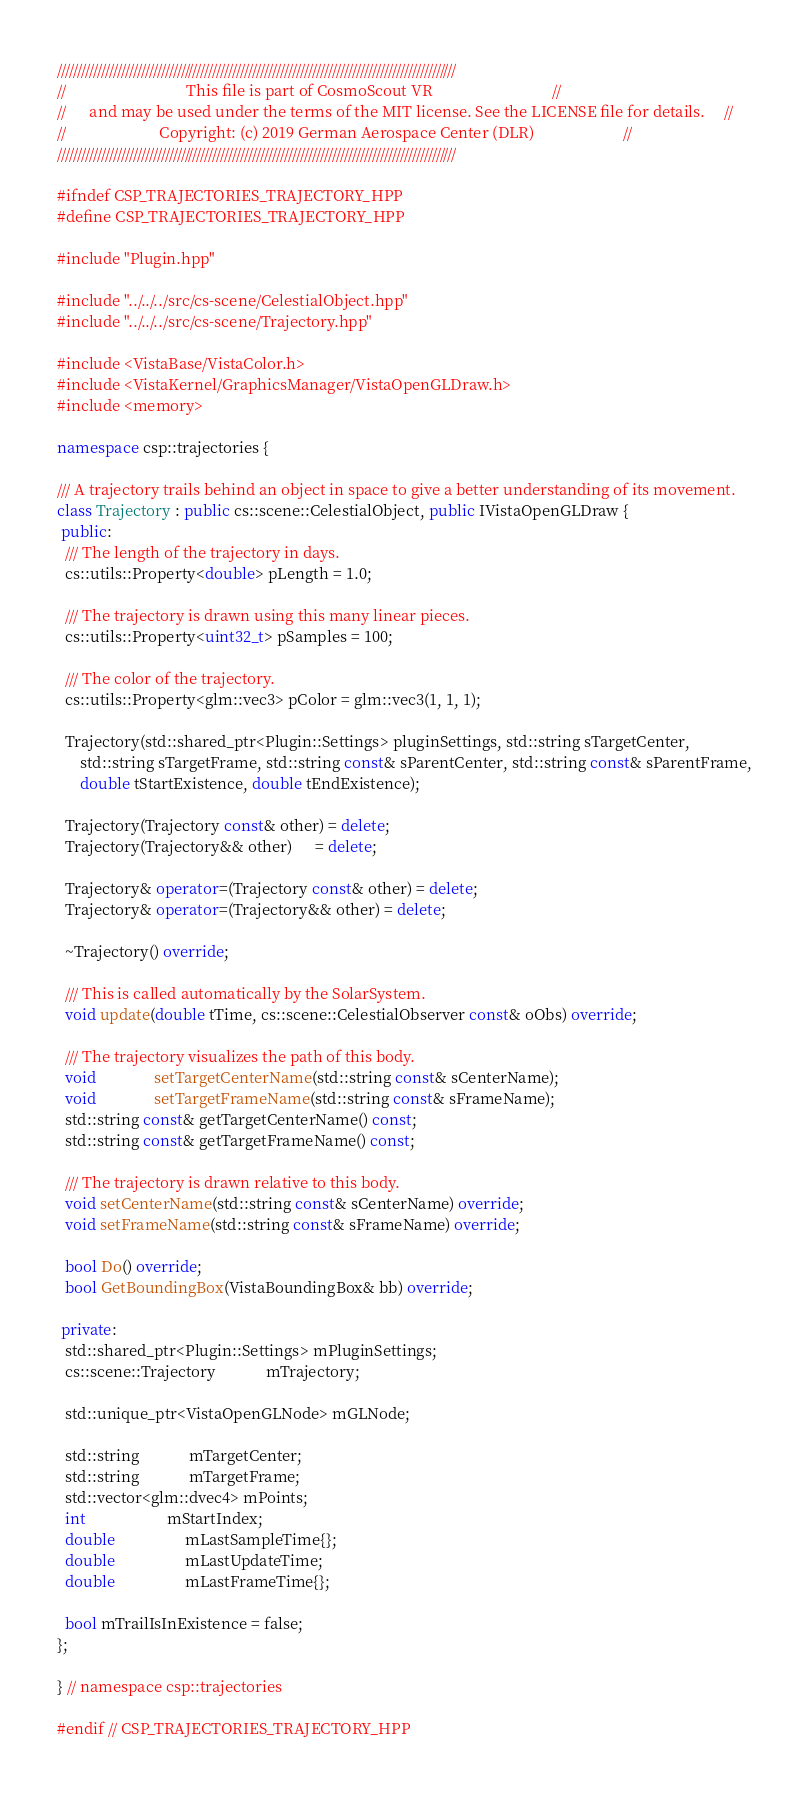Convert code to text. <code><loc_0><loc_0><loc_500><loc_500><_C++_>////////////////////////////////////////////////////////////////////////////////////////////////////
//                               This file is part of CosmoScout VR                               //
//      and may be used under the terms of the MIT license. See the LICENSE file for details.     //
//                        Copyright: (c) 2019 German Aerospace Center (DLR)                       //
////////////////////////////////////////////////////////////////////////////////////////////////////

#ifndef CSP_TRAJECTORIES_TRAJECTORY_HPP
#define CSP_TRAJECTORIES_TRAJECTORY_HPP

#include "Plugin.hpp"

#include "../../../src/cs-scene/CelestialObject.hpp"
#include "../../../src/cs-scene/Trajectory.hpp"

#include <VistaBase/VistaColor.h>
#include <VistaKernel/GraphicsManager/VistaOpenGLDraw.h>
#include <memory>

namespace csp::trajectories {

/// A trajectory trails behind an object in space to give a better understanding of its movement.
class Trajectory : public cs::scene::CelestialObject, public IVistaOpenGLDraw {
 public:
  /// The length of the trajectory in days.
  cs::utils::Property<double> pLength = 1.0;

  /// The trajectory is drawn using this many linear pieces.
  cs::utils::Property<uint32_t> pSamples = 100;

  /// The color of the trajectory.
  cs::utils::Property<glm::vec3> pColor = glm::vec3(1, 1, 1);

  Trajectory(std::shared_ptr<Plugin::Settings> pluginSettings, std::string sTargetCenter,
      std::string sTargetFrame, std::string const& sParentCenter, std::string const& sParentFrame,
      double tStartExistence, double tEndExistence);

  Trajectory(Trajectory const& other) = delete;
  Trajectory(Trajectory&& other)      = delete;

  Trajectory& operator=(Trajectory const& other) = delete;
  Trajectory& operator=(Trajectory&& other) = delete;

  ~Trajectory() override;

  /// This is called automatically by the SolarSystem.
  void update(double tTime, cs::scene::CelestialObserver const& oObs) override;

  /// The trajectory visualizes the path of this body.
  void               setTargetCenterName(std::string const& sCenterName);
  void               setTargetFrameName(std::string const& sFrameName);
  std::string const& getTargetCenterName() const;
  std::string const& getTargetFrameName() const;

  /// The trajectory is drawn relative to this body.
  void setCenterName(std::string const& sCenterName) override;
  void setFrameName(std::string const& sFrameName) override;

  bool Do() override;
  bool GetBoundingBox(VistaBoundingBox& bb) override;

 private:
  std::shared_ptr<Plugin::Settings> mPluginSettings;
  cs::scene::Trajectory             mTrajectory;

  std::unique_ptr<VistaOpenGLNode> mGLNode;

  std::string             mTargetCenter;
  std::string             mTargetFrame;
  std::vector<glm::dvec4> mPoints;
  int                     mStartIndex;
  double                  mLastSampleTime{};
  double                  mLastUpdateTime;
  double                  mLastFrameTime{};

  bool mTrailIsInExistence = false;
};

} // namespace csp::trajectories

#endif // CSP_TRAJECTORIES_TRAJECTORY_HPP
</code> 